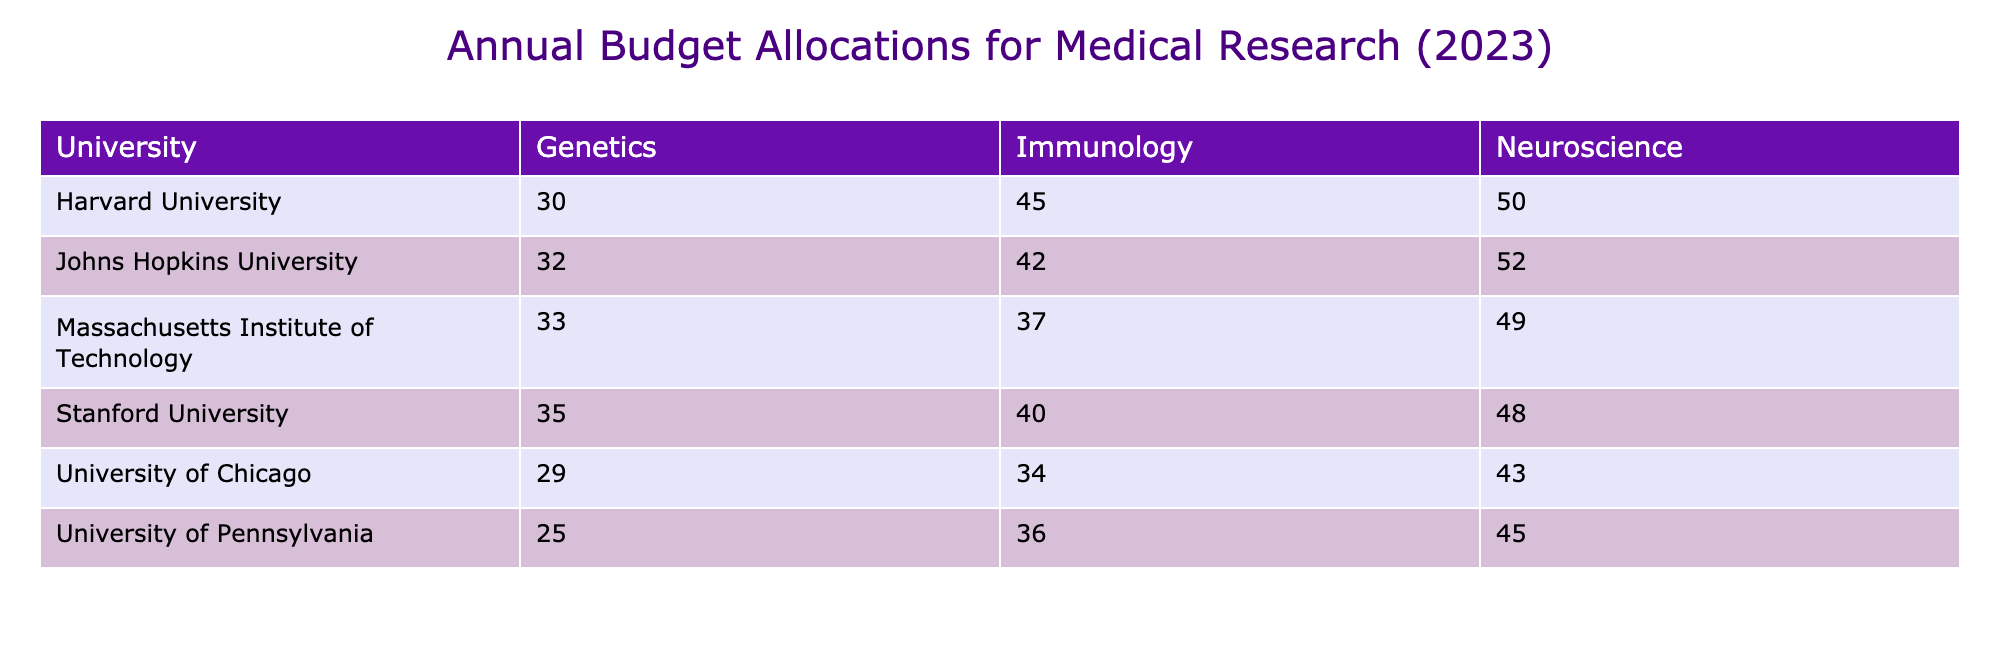What is the annual budget for Immunology at Harvard University? The table lists Harvard University's Immunology budget for 2023 as 45 million USD. This value is directly found in the table under the respective row and column.
Answer: 45 million USD Which university has the highest annual budget allocated to Neuroscience? By comparing the values in the Neuroscience column, Johns Hopkins University, with a budget of 52 million USD, has the highest allocation for Neuroscience in 2023.
Answer: Johns Hopkins University What is the total annual budget for Genetics across all universities? To find this, we need to sum the budgets for the Genetics department from each university: Harvard (30) + Stanford (35) + Johns Hopkins (32) + Pennsylvania (25) + MIT (33) + Chicago (29). The total is 30 + 35 + 32 + 25 + 33 + 29 = 184 million USD.
Answer: 184 million USD Is the annual budget for Immunology at Stanford University higher than that at the University of Pennsylvania? Stanford University's budget for Immunology is 40 million USD, while the University of Pennsylvania's budget is 36 million USD; thus, 40 million is indeed greater than 36 million.
Answer: Yes What is the average annual budget allocated for Neuroscience across all the mentioned universities? First, we gather the annual budgets for Neuroscience: Harvard (50), Stanford (48), Johns Hopkins (52), Pennsylvania (45), MIT (49), Chicago (43). The total is 50 + 48 + 52 + 45 + 49 + 43 = 287 million USD. There are 6 universities, so we divide 287 by 6, which gives approximately 47.83 million USD.
Answer: Approximately 47.83 million USD 